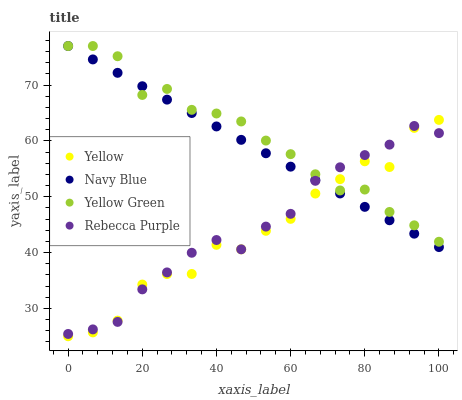Does Yellow have the minimum area under the curve?
Answer yes or no. Yes. Does Yellow Green have the maximum area under the curve?
Answer yes or no. Yes. Does Yellow Green have the minimum area under the curve?
Answer yes or no. No. Does Yellow have the maximum area under the curve?
Answer yes or no. No. Is Navy Blue the smoothest?
Answer yes or no. Yes. Is Yellow the roughest?
Answer yes or no. Yes. Is Yellow Green the smoothest?
Answer yes or no. No. Is Yellow Green the roughest?
Answer yes or no. No. Does Yellow have the lowest value?
Answer yes or no. Yes. Does Yellow Green have the lowest value?
Answer yes or no. No. Does Yellow Green have the highest value?
Answer yes or no. Yes. Does Yellow have the highest value?
Answer yes or no. No. Does Navy Blue intersect Yellow Green?
Answer yes or no. Yes. Is Navy Blue less than Yellow Green?
Answer yes or no. No. Is Navy Blue greater than Yellow Green?
Answer yes or no. No. 